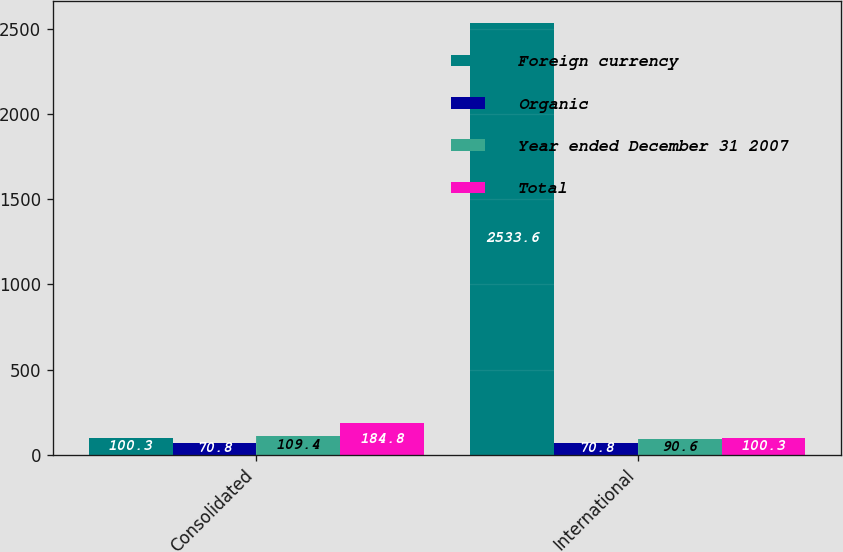Convert chart to OTSL. <chart><loc_0><loc_0><loc_500><loc_500><stacked_bar_chart><ecel><fcel>Consolidated<fcel>International<nl><fcel>Foreign currency<fcel>100.3<fcel>2533.6<nl><fcel>Organic<fcel>70.8<fcel>70.8<nl><fcel>Year ended December 31 2007<fcel>109.4<fcel>90.6<nl><fcel>Total<fcel>184.8<fcel>100.3<nl></chart> 